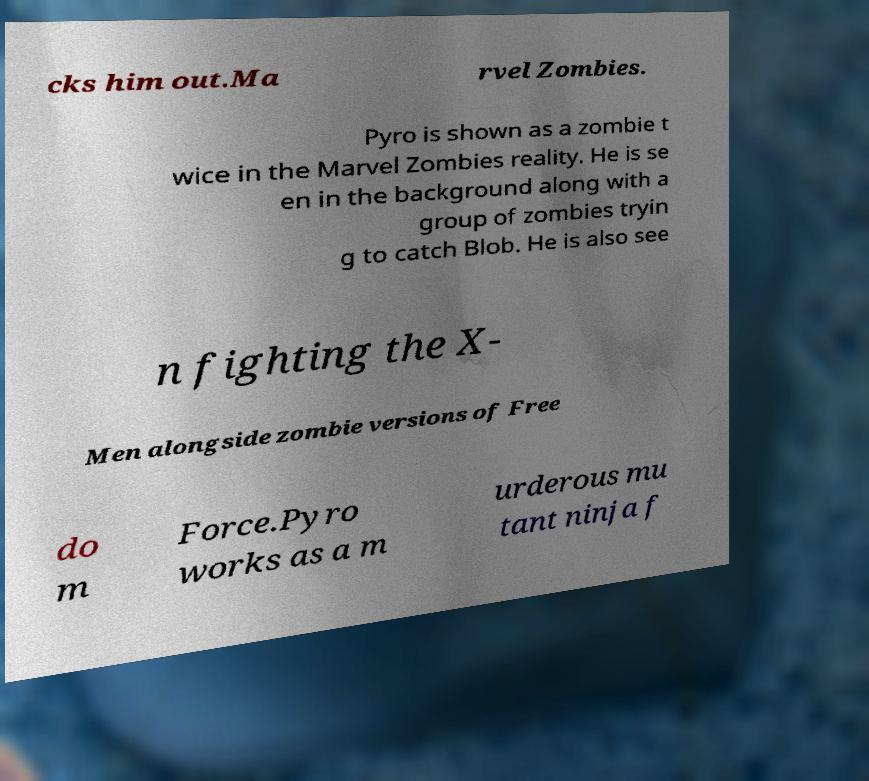Can you read and provide the text displayed in the image?This photo seems to have some interesting text. Can you extract and type it out for me? cks him out.Ma rvel Zombies. Pyro is shown as a zombie t wice in the Marvel Zombies reality. He is se en in the background along with a group of zombies tryin g to catch Blob. He is also see n fighting the X- Men alongside zombie versions of Free do m Force.Pyro works as a m urderous mu tant ninja f 